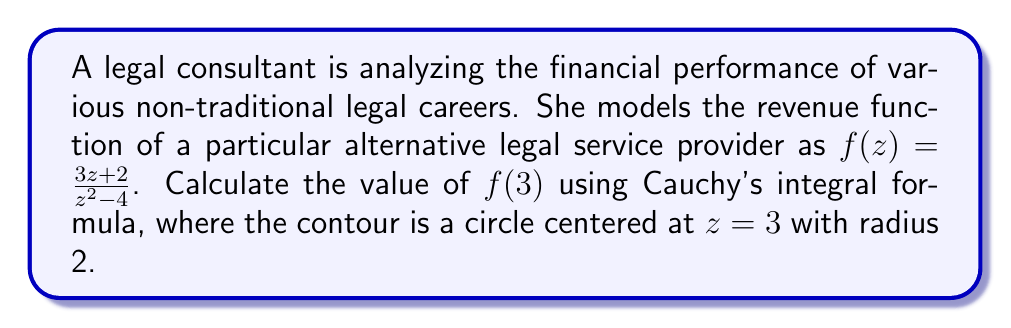Teach me how to tackle this problem. To solve this problem using Cauchy's integral formula, we'll follow these steps:

1) Cauchy's integral formula states that for an analytic function $f(z)$ inside and on a simple closed contour $C$, and for any point $a$ inside $C$:

   $$f(a) = \frac{1}{2\pi i} \oint_C \frac{f(z)}{z-a} dz$$

2) In our case, $a=3$, and $f(z) = \frac{3z+2}{z^2-4}$

3) We need to check if $f(z)$ is analytic inside and on the contour. The only singularities of $f(z)$ are at $z=\pm 2$. The contour is a circle with center at 3 and radius 2, so it doesn't include these singularities.

4) Now we can apply Cauchy's integral formula:

   $$f(3) = \frac{1}{2\pi i} \oint_C \frac{f(z)}{z-3} dz = \frac{1}{2\pi i} \oint_C \frac{\frac{3z+2}{z^2-4}}{z-3} dz$$

5) Simplify the integrand:

   $$f(3) = \frac{1}{2\pi i} \oint_C \frac{3z+2}{(z^2-4)(z-3)} dz$$

6) The value of this integral is exactly $f(3)$, so we don't need to evaluate the integral explicitly.

7) To find $f(3)$, we can simply substitute $z=3$ into the original function:

   $$f(3) = \frac{3(3)+2}{3^2-4} = \frac{11}{5}$$
Answer: $f(3) = \frac{11}{5}$ 